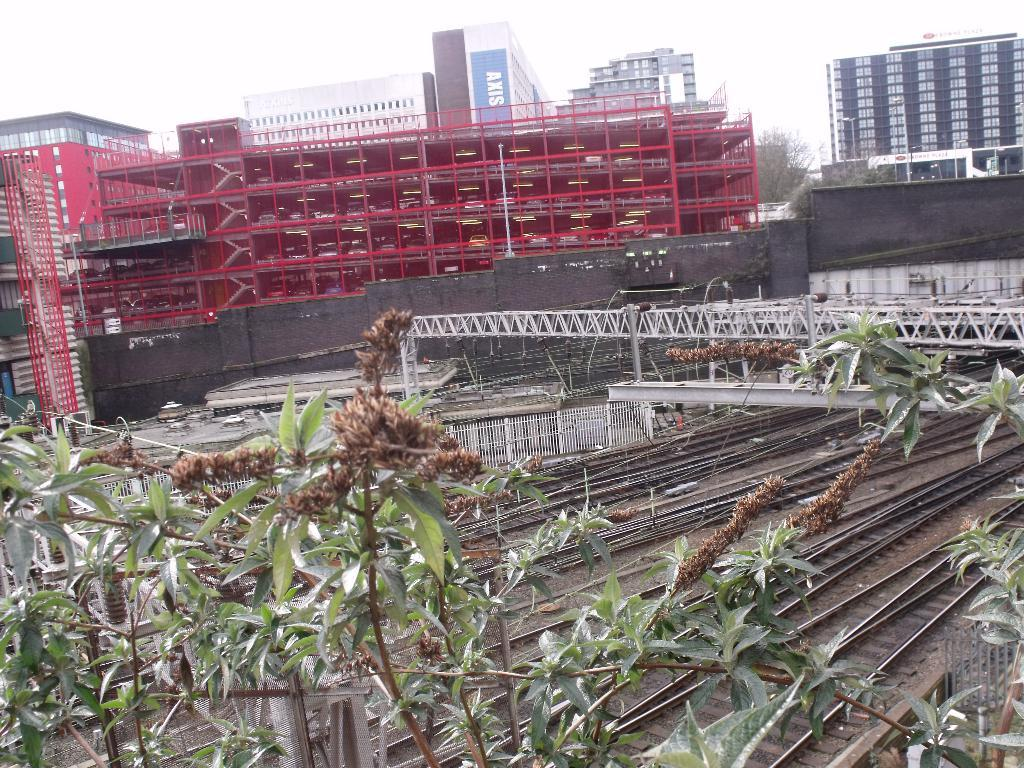What is located in the front of the image? There is a plant in the front of the image. What is behind the plant in the image? There is a railway track behind the plant. How is the railway track positioned in the image? The railway track is on the land. What can be seen in the background of the image? There are buildings in the background of the image. What is visible above the buildings in the image? The sky is visible above the buildings. What type of advertisement can be seen on the plant in the image? There is no advertisement present on the plant in the image; it is a plant without any additional features. 